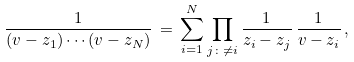Convert formula to latex. <formula><loc_0><loc_0><loc_500><loc_500>\frac { 1 } { ( v - z _ { 1 } ) \cdots ( v - z _ { N } ) } \, = \, \sum _ { i = 1 } ^ { N } \prod _ { j \colon \neq i } \frac { 1 } { z _ { i } - z _ { j } } \, \frac { 1 } { v - z _ { i } } \, ,</formula> 